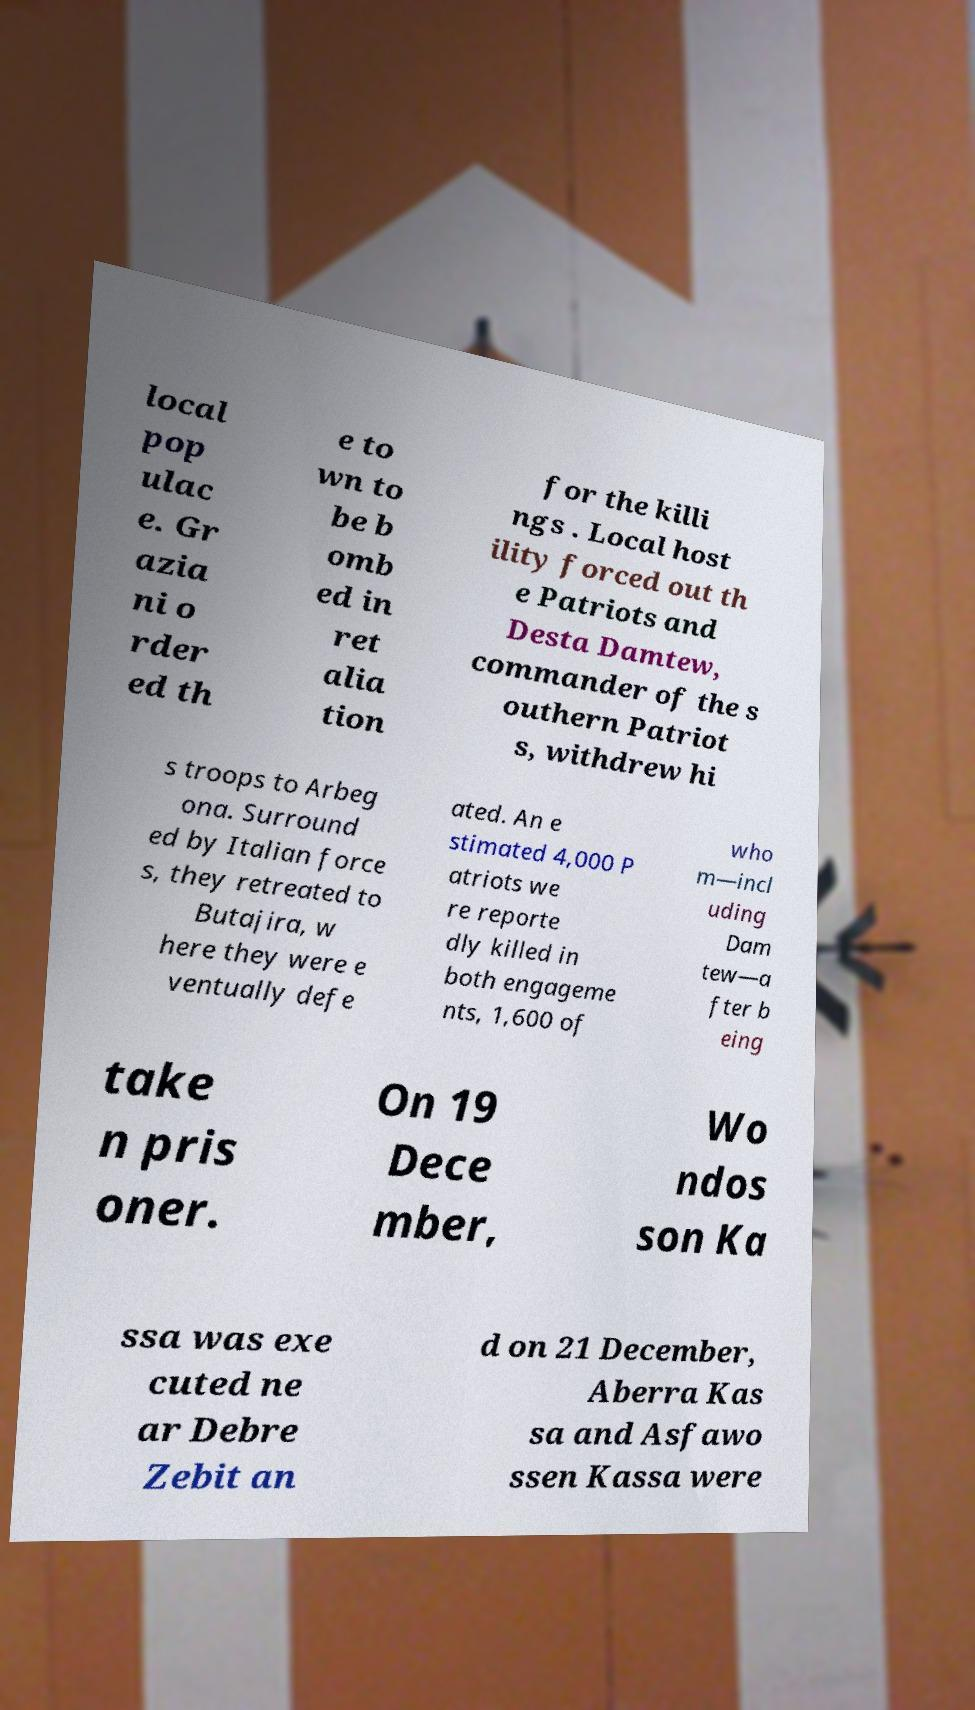What messages or text are displayed in this image? I need them in a readable, typed format. local pop ulac e. Gr azia ni o rder ed th e to wn to be b omb ed in ret alia tion for the killi ngs . Local host ility forced out th e Patriots and Desta Damtew, commander of the s outhern Patriot s, withdrew hi s troops to Arbeg ona. Surround ed by Italian force s, they retreated to Butajira, w here they were e ventually defe ated. An e stimated 4,000 P atriots we re reporte dly killed in both engageme nts, 1,600 of who m—incl uding Dam tew—a fter b eing take n pris oner. On 19 Dece mber, Wo ndos son Ka ssa was exe cuted ne ar Debre Zebit an d on 21 December, Aberra Kas sa and Asfawo ssen Kassa were 